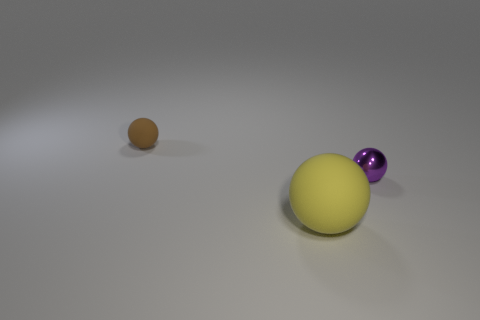Add 3 tiny purple shiny cylinders. How many objects exist? 6 Subtract all brown spheres. How many spheres are left? 2 Subtract all small brown matte spheres. How many spheres are left? 2 Add 2 cyan matte things. How many cyan matte things exist? 2 Subtract 1 purple spheres. How many objects are left? 2 Subtract all blue spheres. Subtract all red blocks. How many spheres are left? 3 Subtract all red cubes. How many brown spheres are left? 1 Subtract all big yellow cubes. Subtract all yellow spheres. How many objects are left? 2 Add 2 brown rubber balls. How many brown rubber balls are left? 3 